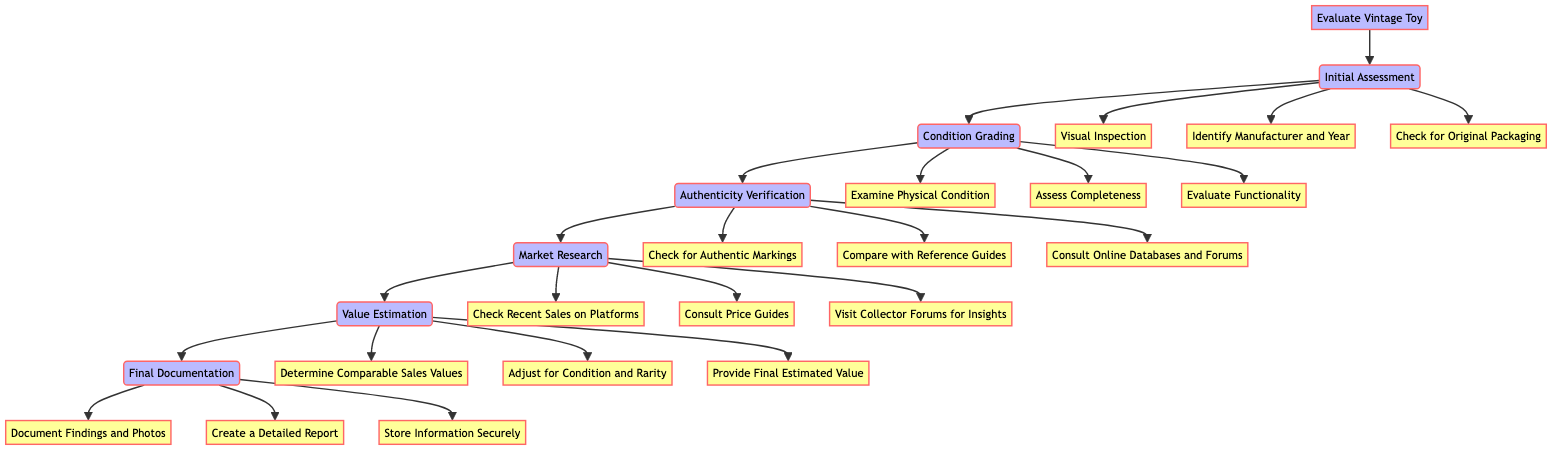What's the first step in evaluating a vintage toy? The first step in the flowchart is "Initial Assessment," which connects directly to the "Evaluate Vintage Toy" node at the top of the diagram.
Answer: Initial Assessment How many actions are listed under "Condition Grading"? The "Condition Grading" node has three specific actions listed as subsequent nodes: "Examine Physical Condition," "Assess Completeness," and "Evaluate Functionality." Counting these gives three actions.
Answer: 3 What action follows "Market Research"? According to the flowchart, after the "Market Research" step, the next step is "Value Estimation." This is explicitly shown as a direct flow from "Market Research" to "Value Estimation."
Answer: Value Estimation Which actions are checked during the "Authenticity Verification"? The actions listed under "Authenticity Verification," which are its connected nodes, include "Check for Authentic Markings," "Compare with Reference Guides," and "Consult Online Databases and Forums." The answer includes all these connected actions.
Answer: Check for Authentic Markings, Compare with Reference Guides, Consult Online Databases and Forums What is the purpose of the "Final Documentation" step? The "Final Documentation" step includes three actions: "Document Findings and Photos," "Create a Detailed Report," and "Store Information Securely." The purpose is to ensure all findings and details are properly recorded and secured.
Answer: Document Findings and Photos, Create a Detailed Report, Store Information Securely How does the step "Value Estimation" relate to "Market Research"? The step "Value Estimation" follows "Market Research" directly, indicating that the findings from market research directly inform the value estimation process, relying on insights gathered in the previous step.
Answer: Value Estimation follows Market Research What is the total number of nodes representing actions in the flowchart? Counting all action nodes under each step, we have 18 actions listed: 3 in "Initial Assessment," 3 in "Condition Grading," 3 in "Authenticity Verification," 3 in "Market Research," 3 in "Value Estimation," and 3 in "Final Documentation." Totalling them gives 18 actions.
Answer: 18 Identify the last action in the diagram The last node connected to the flow is "Store Information Securely" under the "Final Documentation" step, which makes it the final action in the process.
Answer: Store Information Securely What must you do before "Value Estimation"? Before reaching "Value Estimation," you must complete "Market Research," ensuring that you gather the necessary data about comparable sales and pricing before estimating value.
Answer: Market Research 